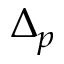Convert formula to latex. <formula><loc_0><loc_0><loc_500><loc_500>\Delta _ { p }</formula> 